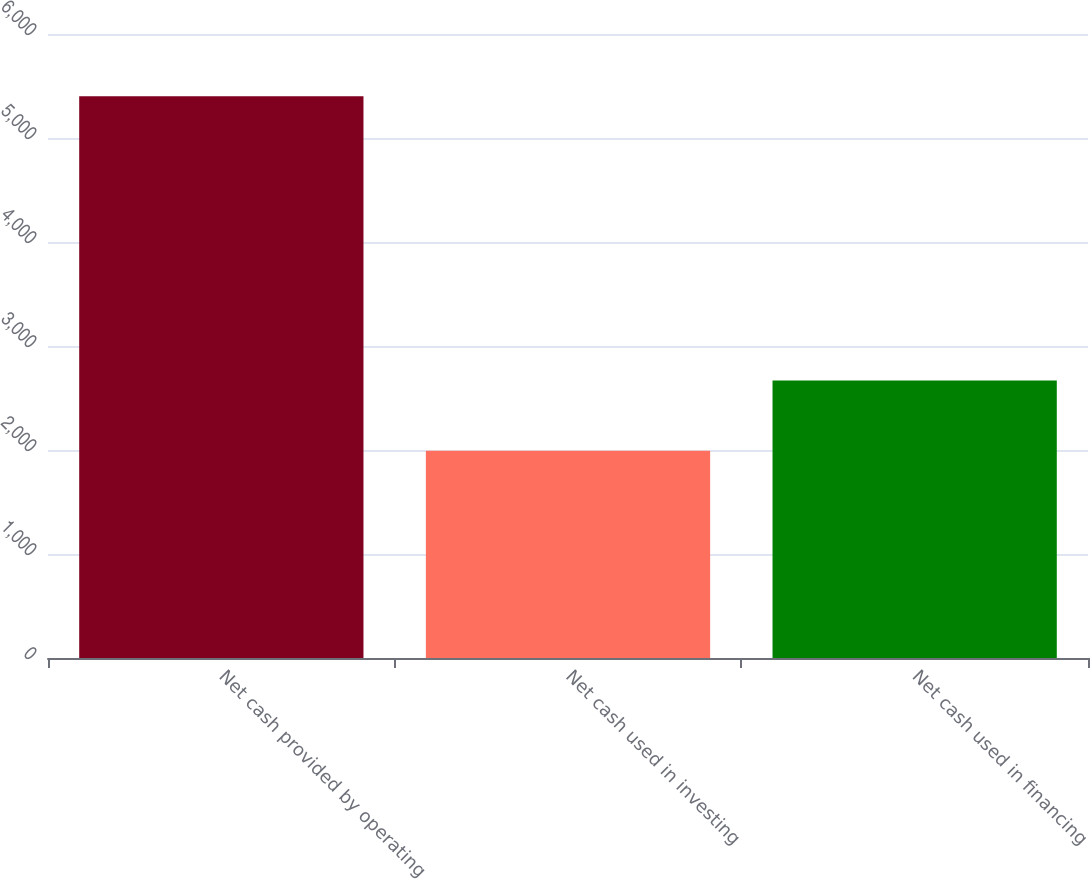Convert chart. <chart><loc_0><loc_0><loc_500><loc_500><bar_chart><fcel>Net cash provided by operating<fcel>Net cash used in investing<fcel>Net cash used in financing<nl><fcel>5401<fcel>1992<fcel>2668<nl></chart> 